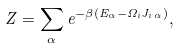Convert formula to latex. <formula><loc_0><loc_0><loc_500><loc_500>Z = \sum _ { \alpha } e ^ { - \beta ( E _ { \alpha } - \Omega _ { i } J _ { i \, \alpha } ) } ,</formula> 